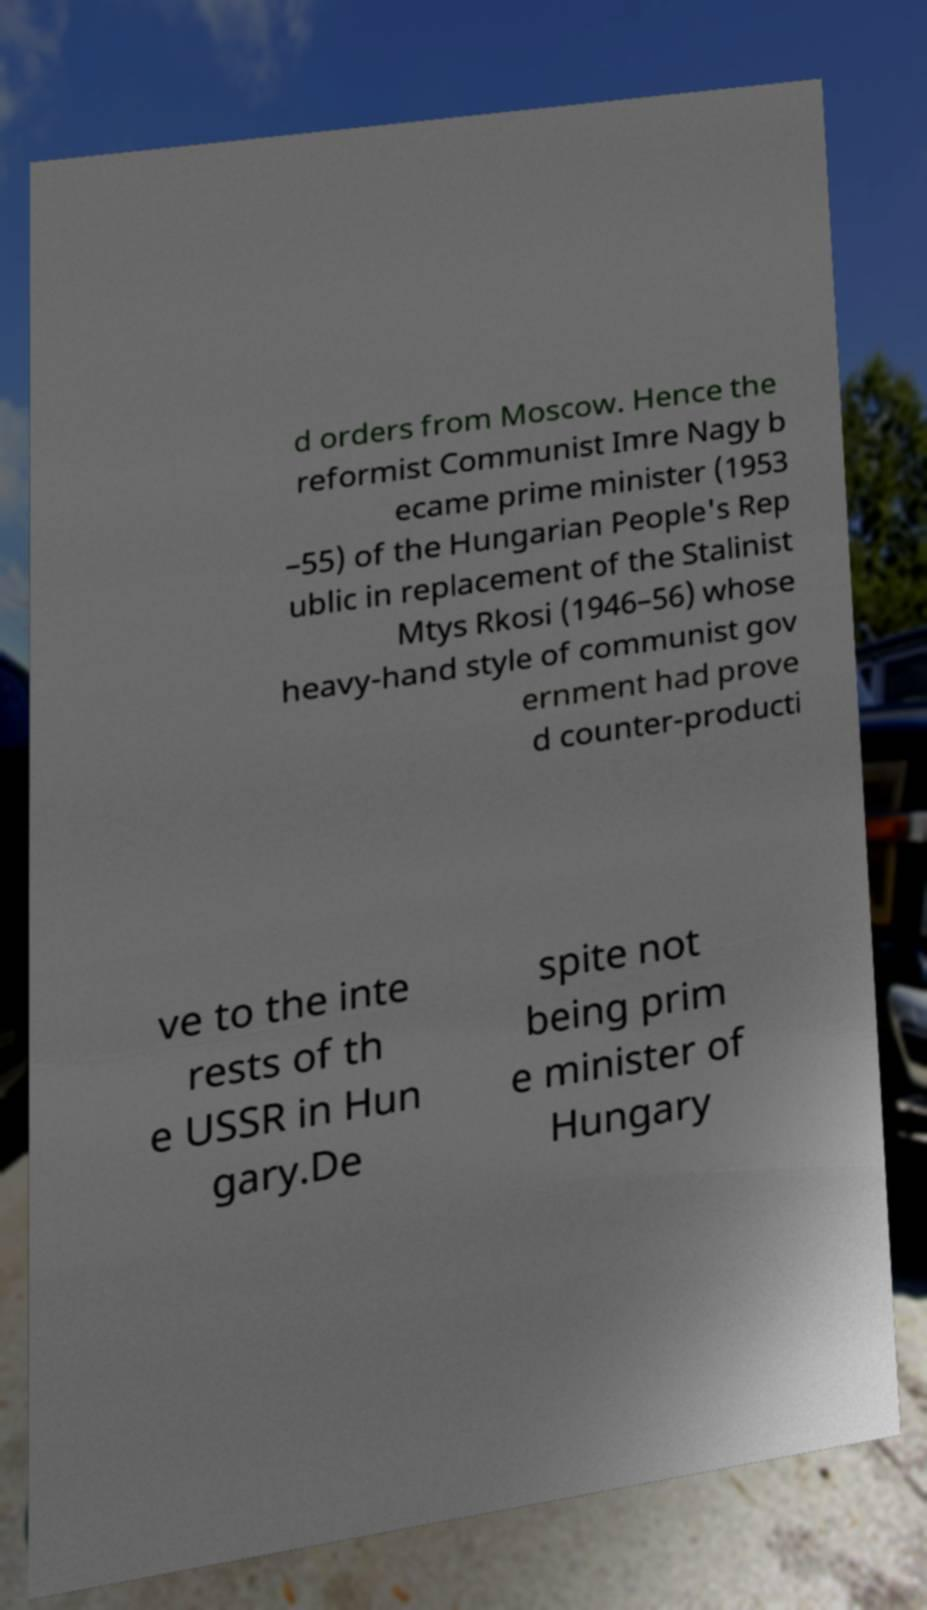Could you assist in decoding the text presented in this image and type it out clearly? d orders from Moscow. Hence the reformist Communist Imre Nagy b ecame prime minister (1953 –55) of the Hungarian People's Rep ublic in replacement of the Stalinist Mtys Rkosi (1946–56) whose heavy-hand style of communist gov ernment had prove d counter-producti ve to the inte rests of th e USSR in Hun gary.De spite not being prim e minister of Hungary 